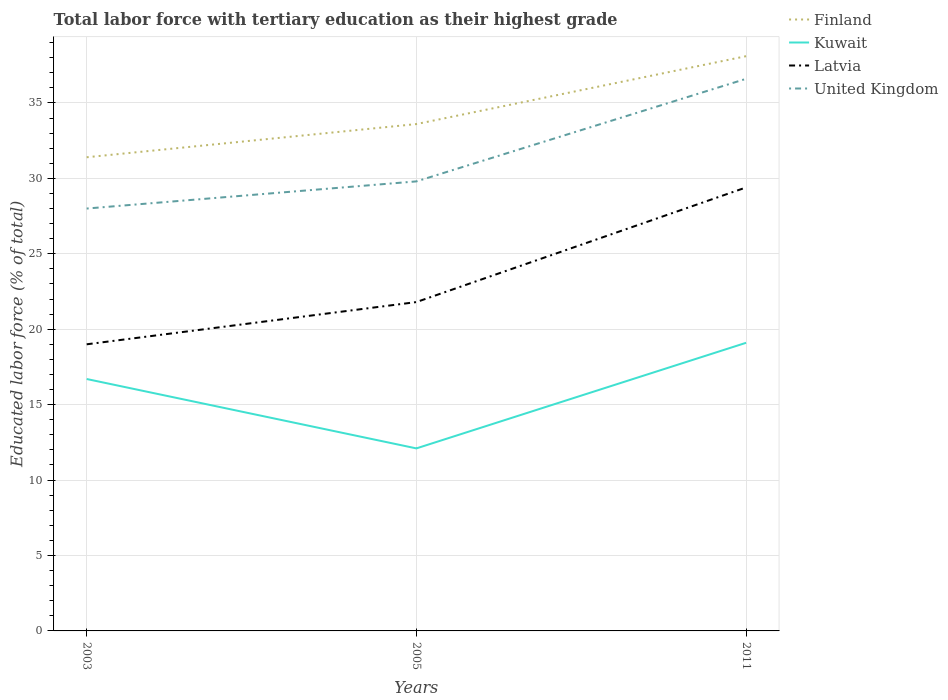Across all years, what is the maximum percentage of male labor force with tertiary education in United Kingdom?
Offer a terse response. 28. In which year was the percentage of male labor force with tertiary education in Latvia maximum?
Your response must be concise. 2003. What is the total percentage of male labor force with tertiary education in United Kingdom in the graph?
Provide a succinct answer. -6.8. What is the difference between the highest and the second highest percentage of male labor force with tertiary education in Finland?
Provide a succinct answer. 6.7. What is the difference between the highest and the lowest percentage of male labor force with tertiary education in Finland?
Provide a succinct answer. 1. Is the percentage of male labor force with tertiary education in Latvia strictly greater than the percentage of male labor force with tertiary education in Finland over the years?
Give a very brief answer. Yes. How many lines are there?
Your answer should be compact. 4. What is the difference between two consecutive major ticks on the Y-axis?
Keep it short and to the point. 5. Does the graph contain grids?
Your answer should be compact. Yes. Where does the legend appear in the graph?
Keep it short and to the point. Top right. How are the legend labels stacked?
Keep it short and to the point. Vertical. What is the title of the graph?
Provide a short and direct response. Total labor force with tertiary education as their highest grade. What is the label or title of the Y-axis?
Offer a terse response. Educated labor force (% of total). What is the Educated labor force (% of total) of Finland in 2003?
Offer a terse response. 31.4. What is the Educated labor force (% of total) of Kuwait in 2003?
Give a very brief answer. 16.7. What is the Educated labor force (% of total) of Finland in 2005?
Make the answer very short. 33.6. What is the Educated labor force (% of total) in Kuwait in 2005?
Provide a short and direct response. 12.1. What is the Educated labor force (% of total) of Latvia in 2005?
Provide a short and direct response. 21.8. What is the Educated labor force (% of total) of United Kingdom in 2005?
Provide a succinct answer. 29.8. What is the Educated labor force (% of total) of Finland in 2011?
Keep it short and to the point. 38.1. What is the Educated labor force (% of total) of Kuwait in 2011?
Offer a very short reply. 19.1. What is the Educated labor force (% of total) of Latvia in 2011?
Offer a terse response. 29.4. What is the Educated labor force (% of total) in United Kingdom in 2011?
Your answer should be compact. 36.6. Across all years, what is the maximum Educated labor force (% of total) in Finland?
Make the answer very short. 38.1. Across all years, what is the maximum Educated labor force (% of total) of Kuwait?
Offer a terse response. 19.1. Across all years, what is the maximum Educated labor force (% of total) in Latvia?
Provide a succinct answer. 29.4. Across all years, what is the maximum Educated labor force (% of total) in United Kingdom?
Keep it short and to the point. 36.6. Across all years, what is the minimum Educated labor force (% of total) of Finland?
Your answer should be compact. 31.4. Across all years, what is the minimum Educated labor force (% of total) in Kuwait?
Keep it short and to the point. 12.1. What is the total Educated labor force (% of total) of Finland in the graph?
Keep it short and to the point. 103.1. What is the total Educated labor force (% of total) in Kuwait in the graph?
Your answer should be compact. 47.9. What is the total Educated labor force (% of total) in Latvia in the graph?
Ensure brevity in your answer.  70.2. What is the total Educated labor force (% of total) in United Kingdom in the graph?
Offer a terse response. 94.4. What is the difference between the Educated labor force (% of total) of Kuwait in 2003 and that in 2005?
Provide a succinct answer. 4.6. What is the difference between the Educated labor force (% of total) of Latvia in 2003 and that in 2005?
Provide a short and direct response. -2.8. What is the difference between the Educated labor force (% of total) of United Kingdom in 2003 and that in 2005?
Your answer should be compact. -1.8. What is the difference between the Educated labor force (% of total) of Kuwait in 2003 and that in 2011?
Offer a terse response. -2.4. What is the difference between the Educated labor force (% of total) in United Kingdom in 2003 and that in 2011?
Ensure brevity in your answer.  -8.6. What is the difference between the Educated labor force (% of total) of Finland in 2005 and that in 2011?
Keep it short and to the point. -4.5. What is the difference between the Educated labor force (% of total) in Latvia in 2005 and that in 2011?
Provide a succinct answer. -7.6. What is the difference between the Educated labor force (% of total) in United Kingdom in 2005 and that in 2011?
Your answer should be compact. -6.8. What is the difference between the Educated labor force (% of total) in Finland in 2003 and the Educated labor force (% of total) in Kuwait in 2005?
Make the answer very short. 19.3. What is the difference between the Educated labor force (% of total) of Kuwait in 2003 and the Educated labor force (% of total) of Latvia in 2005?
Ensure brevity in your answer.  -5.1. What is the difference between the Educated labor force (% of total) in Latvia in 2003 and the Educated labor force (% of total) in United Kingdom in 2005?
Keep it short and to the point. -10.8. What is the difference between the Educated labor force (% of total) in Finland in 2003 and the Educated labor force (% of total) in Latvia in 2011?
Your response must be concise. 2. What is the difference between the Educated labor force (% of total) in Kuwait in 2003 and the Educated labor force (% of total) in United Kingdom in 2011?
Your answer should be compact. -19.9. What is the difference between the Educated labor force (% of total) of Latvia in 2003 and the Educated labor force (% of total) of United Kingdom in 2011?
Your response must be concise. -17.6. What is the difference between the Educated labor force (% of total) of Finland in 2005 and the Educated labor force (% of total) of Kuwait in 2011?
Your answer should be very brief. 14.5. What is the difference between the Educated labor force (% of total) in Finland in 2005 and the Educated labor force (% of total) in Latvia in 2011?
Make the answer very short. 4.2. What is the difference between the Educated labor force (% of total) in Finland in 2005 and the Educated labor force (% of total) in United Kingdom in 2011?
Your response must be concise. -3. What is the difference between the Educated labor force (% of total) in Kuwait in 2005 and the Educated labor force (% of total) in Latvia in 2011?
Make the answer very short. -17.3. What is the difference between the Educated labor force (% of total) of Kuwait in 2005 and the Educated labor force (% of total) of United Kingdom in 2011?
Give a very brief answer. -24.5. What is the difference between the Educated labor force (% of total) of Latvia in 2005 and the Educated labor force (% of total) of United Kingdom in 2011?
Ensure brevity in your answer.  -14.8. What is the average Educated labor force (% of total) of Finland per year?
Your answer should be very brief. 34.37. What is the average Educated labor force (% of total) in Kuwait per year?
Make the answer very short. 15.97. What is the average Educated labor force (% of total) in Latvia per year?
Ensure brevity in your answer.  23.4. What is the average Educated labor force (% of total) in United Kingdom per year?
Ensure brevity in your answer.  31.47. In the year 2003, what is the difference between the Educated labor force (% of total) of Kuwait and Educated labor force (% of total) of United Kingdom?
Provide a short and direct response. -11.3. In the year 2005, what is the difference between the Educated labor force (% of total) of Finland and Educated labor force (% of total) of Kuwait?
Provide a succinct answer. 21.5. In the year 2005, what is the difference between the Educated labor force (% of total) in Finland and Educated labor force (% of total) in United Kingdom?
Provide a short and direct response. 3.8. In the year 2005, what is the difference between the Educated labor force (% of total) in Kuwait and Educated labor force (% of total) in United Kingdom?
Your answer should be compact. -17.7. In the year 2005, what is the difference between the Educated labor force (% of total) of Latvia and Educated labor force (% of total) of United Kingdom?
Your answer should be compact. -8. In the year 2011, what is the difference between the Educated labor force (% of total) in Finland and Educated labor force (% of total) in Kuwait?
Provide a succinct answer. 19. In the year 2011, what is the difference between the Educated labor force (% of total) in Finland and Educated labor force (% of total) in United Kingdom?
Offer a terse response. 1.5. In the year 2011, what is the difference between the Educated labor force (% of total) of Kuwait and Educated labor force (% of total) of Latvia?
Keep it short and to the point. -10.3. In the year 2011, what is the difference between the Educated labor force (% of total) in Kuwait and Educated labor force (% of total) in United Kingdom?
Offer a terse response. -17.5. What is the ratio of the Educated labor force (% of total) in Finland in 2003 to that in 2005?
Provide a short and direct response. 0.93. What is the ratio of the Educated labor force (% of total) of Kuwait in 2003 to that in 2005?
Offer a terse response. 1.38. What is the ratio of the Educated labor force (% of total) in Latvia in 2003 to that in 2005?
Your response must be concise. 0.87. What is the ratio of the Educated labor force (% of total) in United Kingdom in 2003 to that in 2005?
Give a very brief answer. 0.94. What is the ratio of the Educated labor force (% of total) of Finland in 2003 to that in 2011?
Offer a terse response. 0.82. What is the ratio of the Educated labor force (% of total) in Kuwait in 2003 to that in 2011?
Keep it short and to the point. 0.87. What is the ratio of the Educated labor force (% of total) in Latvia in 2003 to that in 2011?
Provide a succinct answer. 0.65. What is the ratio of the Educated labor force (% of total) in United Kingdom in 2003 to that in 2011?
Give a very brief answer. 0.77. What is the ratio of the Educated labor force (% of total) of Finland in 2005 to that in 2011?
Ensure brevity in your answer.  0.88. What is the ratio of the Educated labor force (% of total) of Kuwait in 2005 to that in 2011?
Give a very brief answer. 0.63. What is the ratio of the Educated labor force (% of total) in Latvia in 2005 to that in 2011?
Your answer should be very brief. 0.74. What is the ratio of the Educated labor force (% of total) of United Kingdom in 2005 to that in 2011?
Offer a very short reply. 0.81. What is the difference between the highest and the second highest Educated labor force (% of total) in Finland?
Your answer should be compact. 4.5. What is the difference between the highest and the second highest Educated labor force (% of total) in United Kingdom?
Offer a terse response. 6.8. What is the difference between the highest and the lowest Educated labor force (% of total) of Finland?
Make the answer very short. 6.7. What is the difference between the highest and the lowest Educated labor force (% of total) of Kuwait?
Provide a succinct answer. 7. 